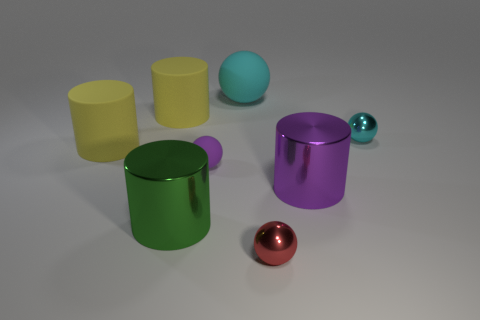What is the shape of the big metallic object that is the same color as the tiny matte object?
Your response must be concise. Cylinder. Is the material of the tiny sphere that is in front of the purple shiny cylinder the same as the cylinder to the right of the green shiny cylinder?
Offer a very short reply. Yes. There is a yellow thing behind the small metallic thing to the right of the big purple object; what shape is it?
Make the answer very short. Cylinder. Are there any large balls to the right of the small metal ball that is behind the big thing that is in front of the purple cylinder?
Ensure brevity in your answer.  No. Do the matte ball on the left side of the large cyan rubber thing and the large object that is to the right of the tiny red sphere have the same color?
Offer a very short reply. Yes. What is the material of the cyan sphere that is the same size as the green object?
Offer a very short reply. Rubber. There is a yellow cylinder in front of the small metallic object behind the tiny object that is in front of the large purple cylinder; how big is it?
Provide a succinct answer. Large. How many other things are there of the same material as the big cyan ball?
Ensure brevity in your answer.  3. What size is the purple thing to the right of the large matte sphere?
Ensure brevity in your answer.  Large. How many large things are behind the large purple metal thing and in front of the small purple object?
Your answer should be compact. 0. 